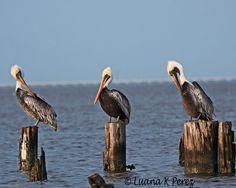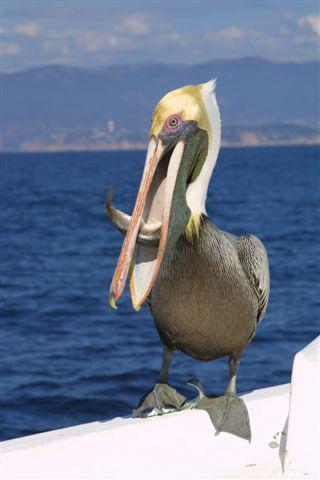The first image is the image on the left, the second image is the image on the right. Examine the images to the left and right. Is the description "The right image contains exactly three birds all looking towards the left." accurate? Answer yes or no. No. 